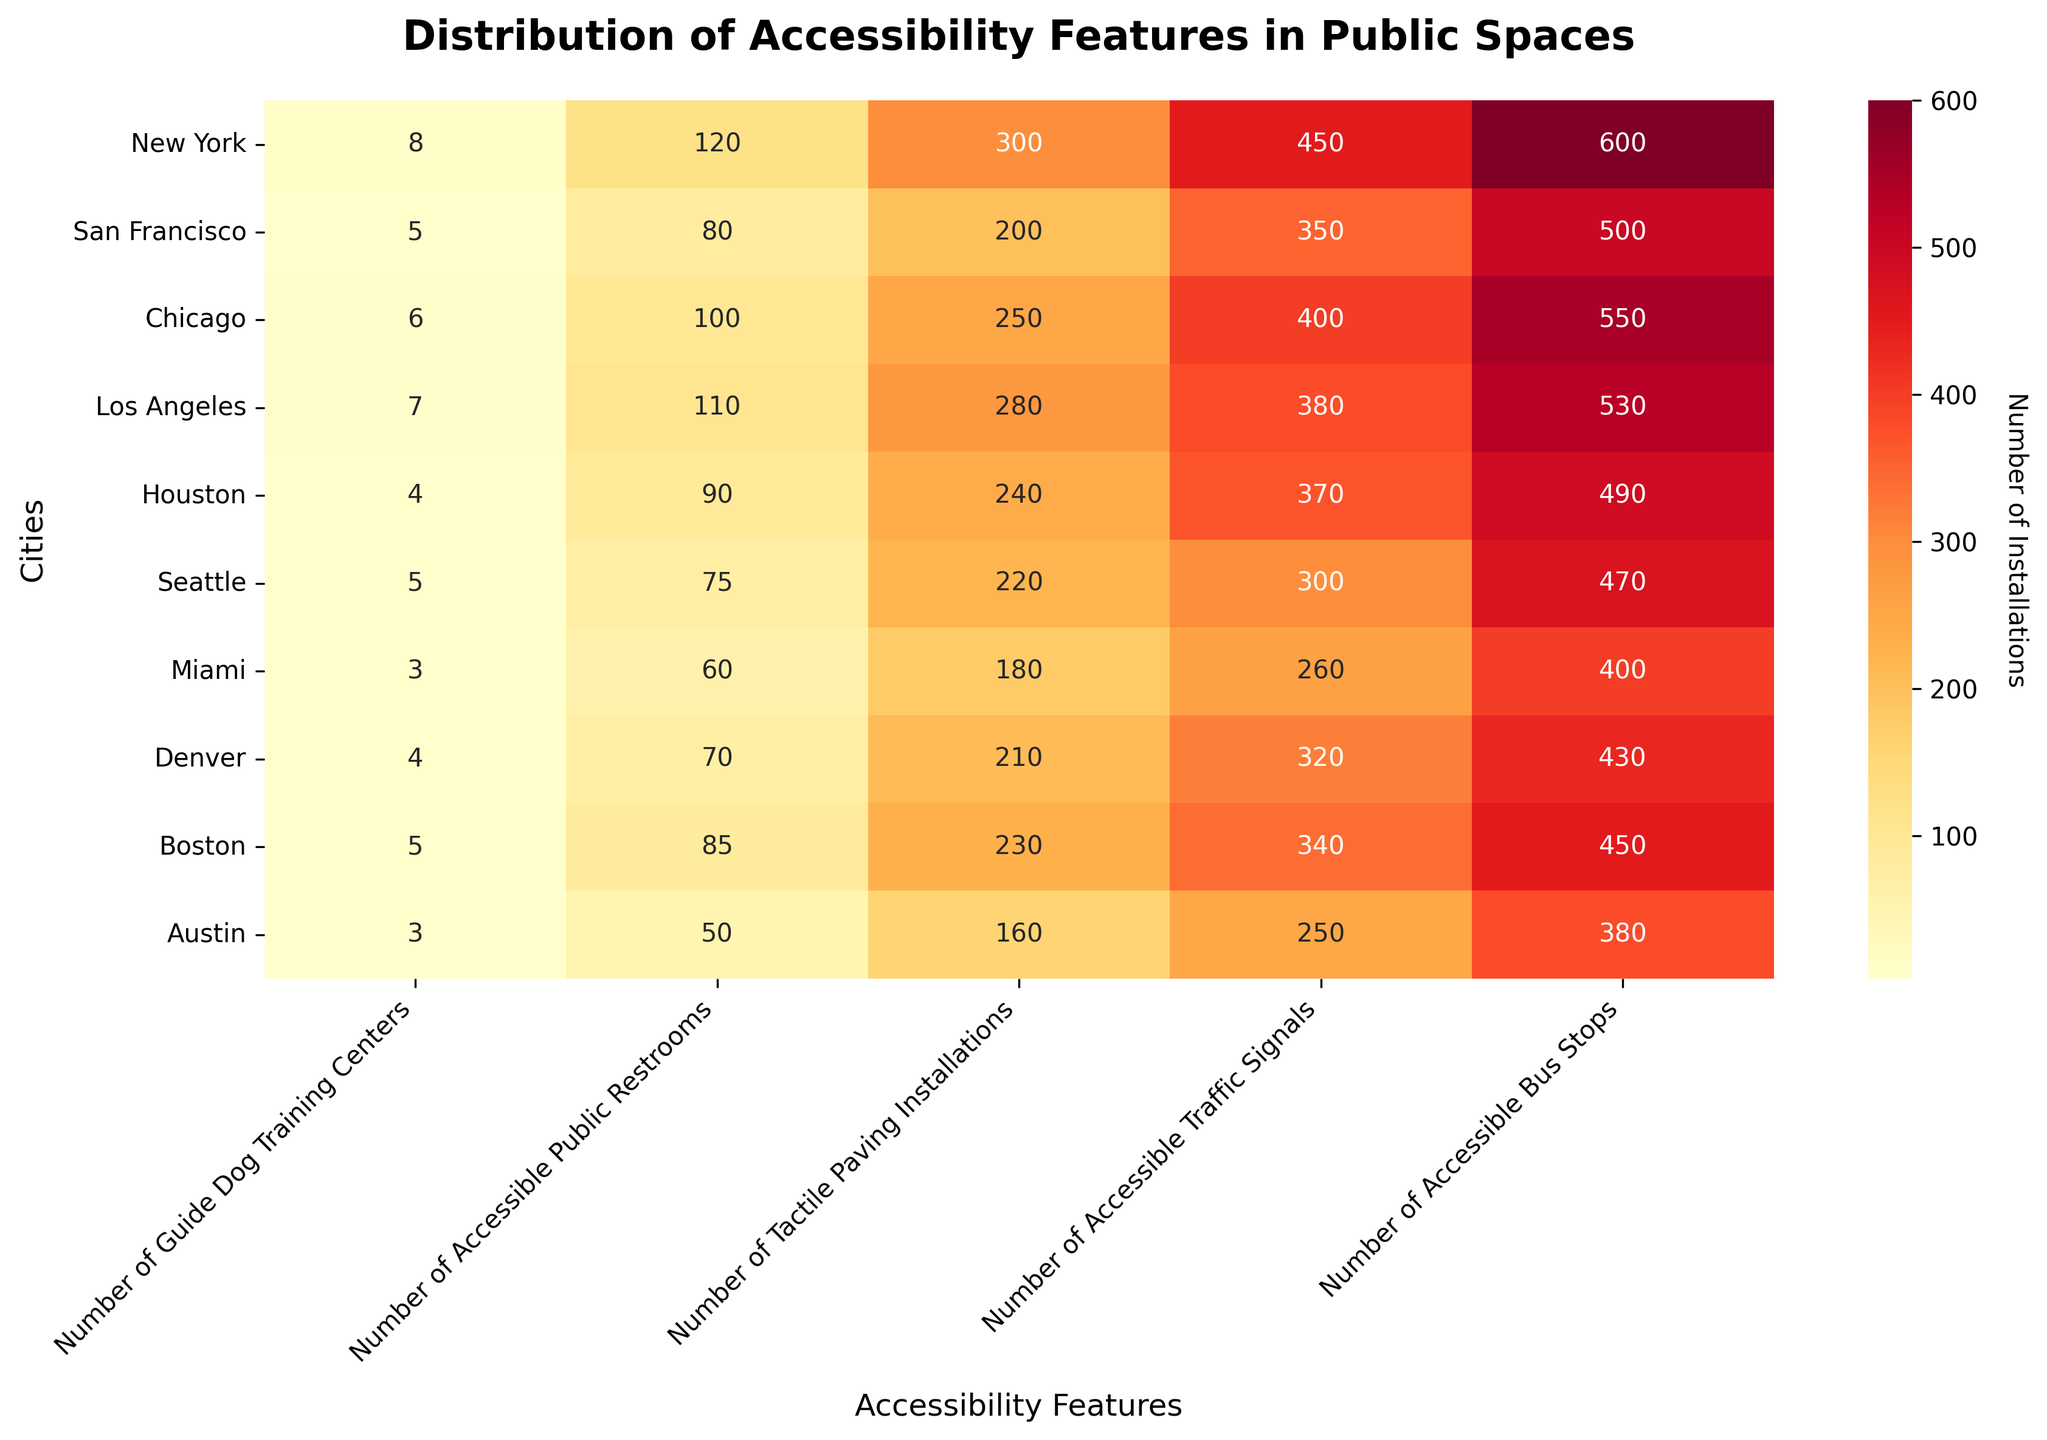What is the title of the heatmap? The title is usually written at the top of the figure and gives a brief description of the data being visualized. From the figure, you can clearly see that the title is "Distribution of Accessibility Features in Public Spaces".
Answer: Distribution of Accessibility Features in Public Spaces Which city has the highest number of accessible bus stops? By locating the "Number of Accessible Bus Stops" column and finding the highest value within that column, you can determine that New York has the highest number of accessible bus stops, with 600 stops.
Answer: New York How many guide dog training centers are there in Denver? To find the number of guide dog training centers in Denver, locate the row for Denver and then identify the value in the "Number of Guide Dog Training Centers" column. Denver has 4 training centers.
Answer: 4 Which accessibility feature has the least number of installations in Miami? By examining the row for Miami and comparing all values, you can determine that the "Number of Guide Dog Training Centers" has the smallest value, which is 3.
Answer: Number of Guide Dog Training Centers What is the total number of tactile paving installations in Chicago and San Francisco combined? You need to add the "Number of Tactile Paving Installations" value for both cities. For Chicago, it is 250 and for San Francisco, it is 200. Their sum is 250 + 200 = 450.
Answer: 450 Which city has fewer accessible traffic signals: Boston or San Francisco? Compare the "Number of Accessible Traffic Signals" values for both cities. Boston has 340 signals, while San Francisco has 350 signals, so Boston has fewer.
Answer: Boston How does the number of accessible public restrooms in Houston compare to Boston? Check the "Number of Accessible Public Restrooms" for both Houston and Boston. Houston has 90 restrooms, while Boston has 85 restrooms. Houston has 5 more than Boston.
Answer: Houston has 5 more What is the average number of accessible bus stops across all cities? Sum the "Number of Accessible Bus Stops" values for all cities and divide by the total number of cities (10). The sum is 600 + 500 + 550 + 530 + 490 + 470 + 400 + 430 + 450 + 380 = 4800. The average is 4800 / 10 = 480.
Answer: 480 Which city has the second highest number of accessible traffic signals? By scanning the "Number of Accessible Traffic Signals" column, identify the highest number first (450 for New York) and then the second highest, which is 400 for Chicago.
Answer: Chicago Is there any city with an equal number of tactile paving installations and accessible public restrooms? Compare values in the columns "Number of Tactile Paving Installations" and "Number of Accessible Public Restrooms" for each city. No city has equal numbers for these features.
Answer: No 